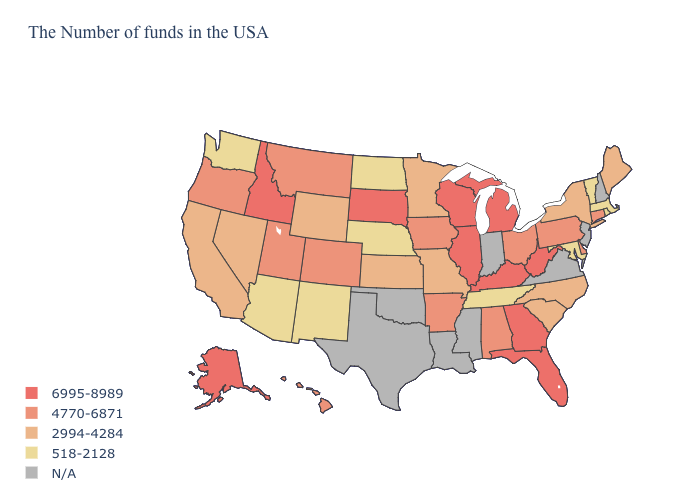Does the first symbol in the legend represent the smallest category?
Be succinct. No. Name the states that have a value in the range 518-2128?
Answer briefly. Massachusetts, Rhode Island, Vermont, Maryland, Tennessee, Nebraska, North Dakota, New Mexico, Arizona, Washington. What is the value of Oklahoma?
Concise answer only. N/A. Does Alaska have the highest value in the West?
Concise answer only. Yes. What is the lowest value in the West?
Answer briefly. 518-2128. What is the lowest value in the MidWest?
Be succinct. 518-2128. Name the states that have a value in the range 6995-8989?
Short answer required. West Virginia, Florida, Georgia, Michigan, Kentucky, Wisconsin, Illinois, South Dakota, Idaho, Alaska. Name the states that have a value in the range 518-2128?
Write a very short answer. Massachusetts, Rhode Island, Vermont, Maryland, Tennessee, Nebraska, North Dakota, New Mexico, Arizona, Washington. Name the states that have a value in the range 518-2128?
Write a very short answer. Massachusetts, Rhode Island, Vermont, Maryland, Tennessee, Nebraska, North Dakota, New Mexico, Arizona, Washington. Is the legend a continuous bar?
Concise answer only. No. Among the states that border South Carolina , does North Carolina have the lowest value?
Answer briefly. Yes. What is the value of Georgia?
Give a very brief answer. 6995-8989. Name the states that have a value in the range 518-2128?
Concise answer only. Massachusetts, Rhode Island, Vermont, Maryland, Tennessee, Nebraska, North Dakota, New Mexico, Arizona, Washington. How many symbols are there in the legend?
Quick response, please. 5. 